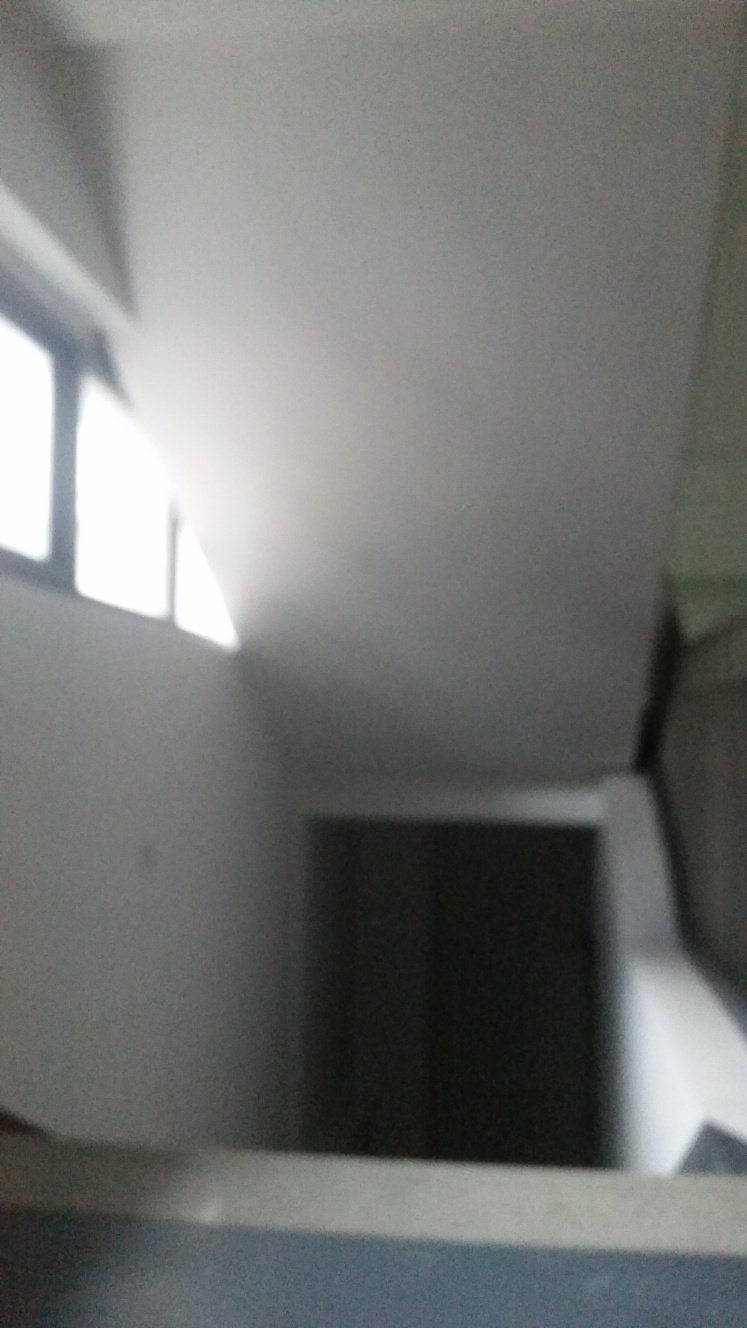Can you suggest ways to improve a photograph like this one? Certainly! To improve a photograph such as this, one should stabilize the camera, perhaps using a tripod or resting on a solid surface. Ensure the camera is focused correctly on the subject. Use a higher shutter speed to avoid motion blur, and if possible, take the photograph in a well-lit environment or use an additional light source to enhance visibility. 